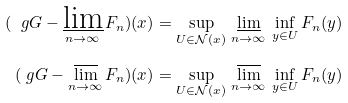Convert formula to latex. <formula><loc_0><loc_0><loc_500><loc_500>( \ g G - \varliminf _ { n \to \infty } F _ { n } ) ( x ) & = \sup _ { U \in \mathcal { N } ( x ) } \, \varliminf _ { n \to \infty } \, \inf _ { y \in U } F _ { n } ( y ) \\ ( \ g G - \varlimsup _ { n \to \infty } F _ { n } ) ( x ) & = \sup _ { U \in \mathcal { N } ( x ) } \, \varlimsup _ { n \to \infty } \, \inf _ { y \in U } F _ { n } ( y )</formula> 